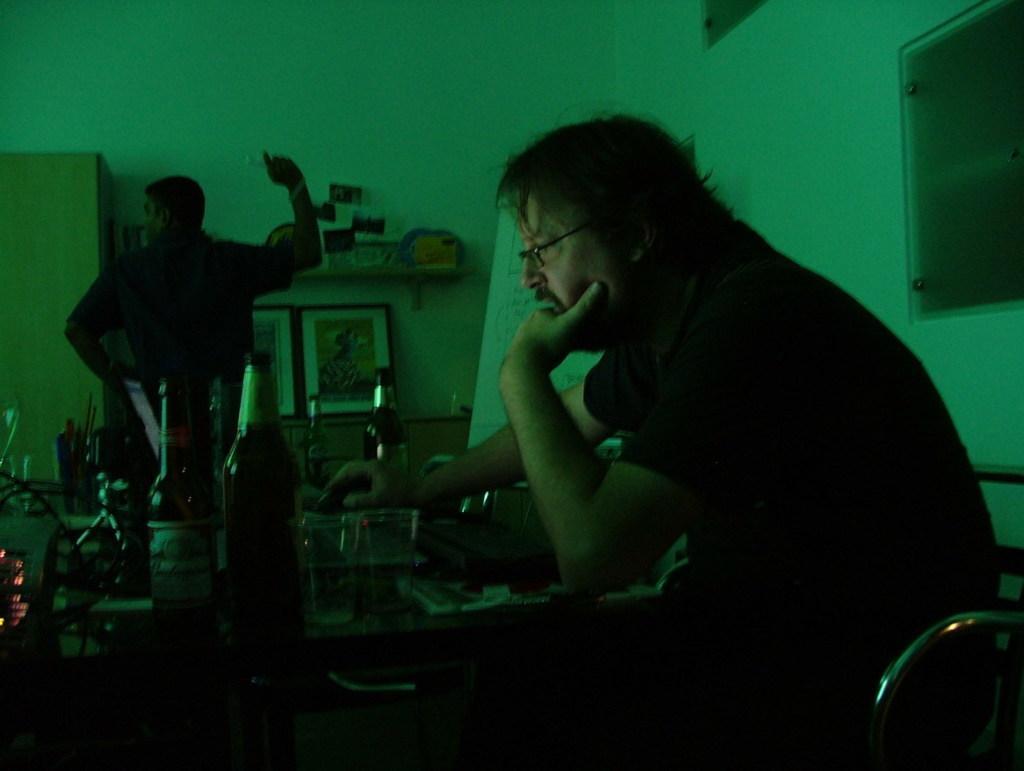Describe this image in one or two sentences. At the bottom of the image a man is sitting and watching. Behind him there is a table, on the table there are some bottles and glasses. Behind the table a man is standing and there is a board. Behind him there is a wall, on the wall there are some frames. 